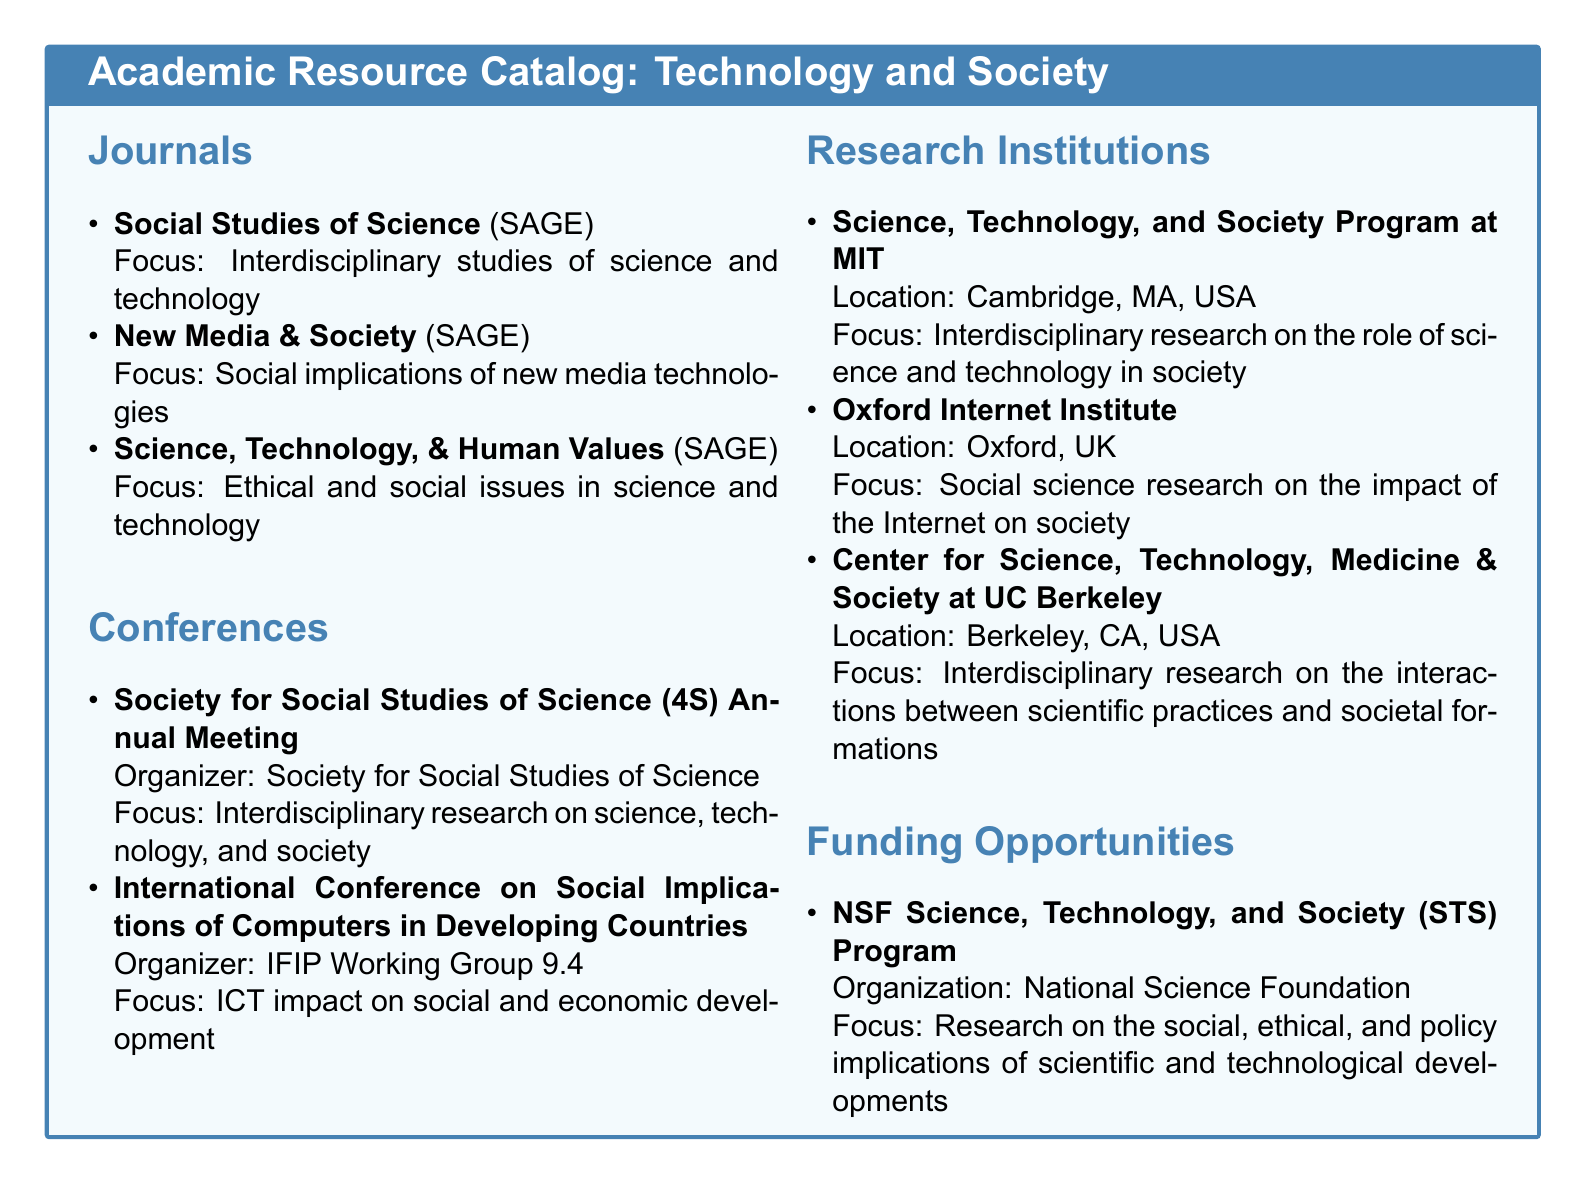What is the title of the catalog? The title of the catalog is the main heading presented in the document, which is "Academic Resource Catalog: Technology and Society".
Answer: Academic Resource Catalog: Technology and Society How many journals are listed in the catalog? The document contains a section titled "Journals", and enumerating the listed journals provides the total count. There are three journals.
Answer: 3 What is the focus of the "New Media & Society" journal? The focus is specified directly under the journal's title in the document. It emphasizes the social implications of new media technologies.
Answer: Social implications of new media technologies Which organization sponsors the "NSF Science, Technology, and Society (STS) Program"? The sponsoring organization is mentioned in relation to the funding opportunities section of the document. It is the National Science Foundation.
Answer: National Science Foundation What is the location of the Oxford Internet Institute? The location of the institution is mentioned directly within its description in the document. It is located in Oxford, UK.
Answer: Oxford, UK What type of research does the "Center for Science, Technology, Medicine & Society at UC Berkeley" focus on? The focus of the center is described as the interactions between scientific practices and societal formations, which is highlighted in the document.
Answer: Interdisciplinary research on the interactions between scientific practices and societal formations What is the main theme of the "Society for Social Studies of Science (4S) Annual Meeting"? The theme is summarized in the focus statement associated with this conference in the document. It addresses interdisciplinary research on science, technology, and society.
Answer: Interdisciplinary research on science, technology, and society Name one key focus of the "Science, Technology, & Human Values" journal. The document specifies the journal's focus as ethical and social issues in science and technology.
Answer: Ethical and social issues in science and technology 